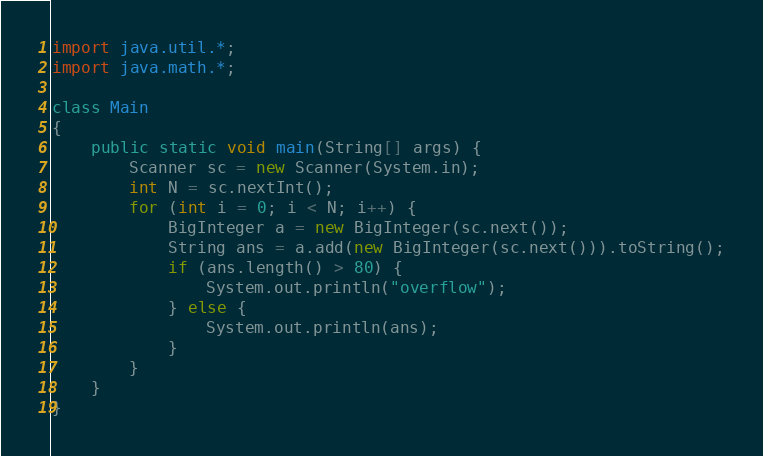<code> <loc_0><loc_0><loc_500><loc_500><_Java_>import java.util.*;
import java.math.*;

class Main
{
    public static void main(String[] args) {
        Scanner sc = new Scanner(System.in);
        int N = sc.nextInt();
        for (int i = 0; i < N; i++) {
            BigInteger a = new BigInteger(sc.next());
            String ans = a.add(new BigInteger(sc.next())).toString();
            if (ans.length() > 80) {
                System.out.println("overflow");
            } else {
                System.out.println(ans);
            }
        }
    }
}</code> 